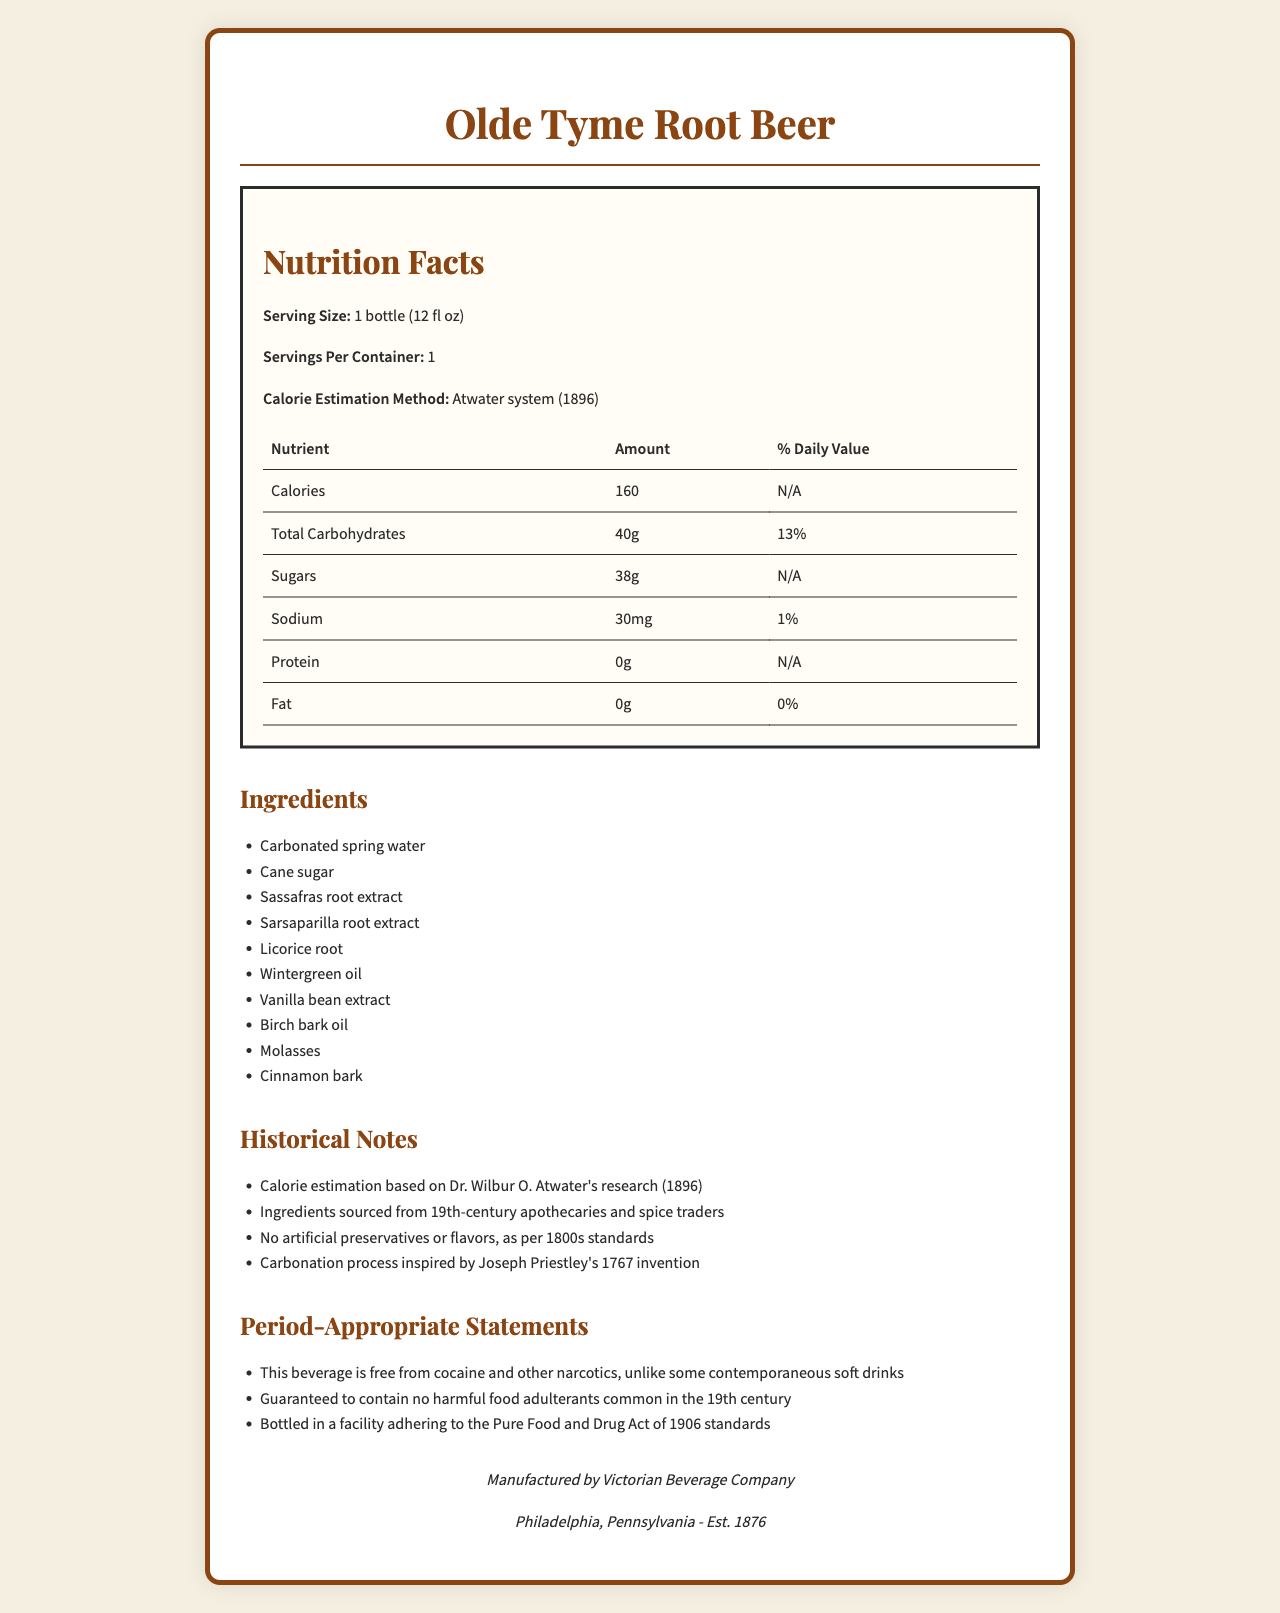what is the serving size? The serving size is clearly listed under the "Serving Size" section of the document.
Answer: 1 bottle (12 fl oz) how many calories are in one serving? The number of calories per serving is directly mentioned under the "Calories" section of the nutrient info table.
Answer: 160 what is the carbohydrate content per serving? The Total Carbohydrates content is listed as 40 grams in the nutrient info table.
Answer: 40g who is the manufacturer of the Olde Tyme Root Beer? The manufacturer's name is listed towards the end of the document in the "manufacturer" section.
Answer: Victorian Beverage Company what is the calorie estimation method used for this root beer? The calorie estimation method is explicitly mentioned under the "Calorie Estimation Method" section in the nutrition facts.
Answer: Atwater system (1896) which of the following ingredients is NOT included in Olde Tyme Root Beer? A. Sarsaparilla root extract B. Licorice root C. Ginger root The ingredients list includes Sarsaparilla root extract and Licorice root but does not mention Ginger root.
Answer: C which historical figure's research is referenced for calorie estimation? A. Louis Pasteur B. Wilbur O. Atwater C. Justus von Liebig The visual document mentions that the calorie estimation is based on Dr. Wilbur O. Atwater's research.
Answer: B is the Olde Tyme Root Beer free from harmful food adulterants common in the 19th century? One of the period-appropriate statements guarantees that the beverage is free from harmful food adulterants common in the 19th century.
Answer: Yes summarize the main idea of the document. The document is primarily focused on conveying the nutritional and ingredient details of a 19th-century inspired gourmet root beer, along with some historical context and manufacturer information.
Answer: The document provides a detailed nutrition facts label for Olde Tyme Root Beer, listing the ingredients, nutritional content, calorie estimation method, historical notes, period-appropriate statements, and manufacturer information. what year was the Victorian Beverage Company established? The document states in the manufacturer section that the company was established in 1876.
Answer: 1876 what is the sodium content in one serving of this root beer? The sodium content per serving is listed as 30 milligrams in the nutrient info table.
Answer: 30mg does this root beer contain any artificial preservatives or flavors? The historical notes section mentions that the beverage contains no artificial preservatives or flavors, adhering to 1800s standards.
Answer: No is there any information on protein content in this root beer? The nutrient info table lists the protein content as 0 grams.
Answer: Yes how was the carbonation process inspired? The historical notes mention that the carbonation process was inspired by Joseph Priestley's 1767 invention.
Answer: Joseph Priestley's 1767 invention what percentage of the daily value for total carbohydrates does one serving cover? The nutrient info table states that the Total Carbohydrates amount per serving is 40g, which covers 13% of the daily value.
Answer: 13% does the document include any information about the calorie content from fats? The document lists various nutrients, but there’s no specific mention of calorie content derived from fats.
Answer: No 